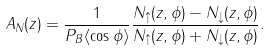Convert formula to latex. <formula><loc_0><loc_0><loc_500><loc_500>A _ { N } ( z ) = \frac { 1 } { P _ { B } \langle \cos \phi \rangle } \frac { N _ { \uparrow } ( z , \phi ) - N _ { \downarrow } ( z , \phi ) } { N _ { \uparrow } ( z , \phi ) + N _ { \downarrow } ( z , \phi ) } .</formula> 